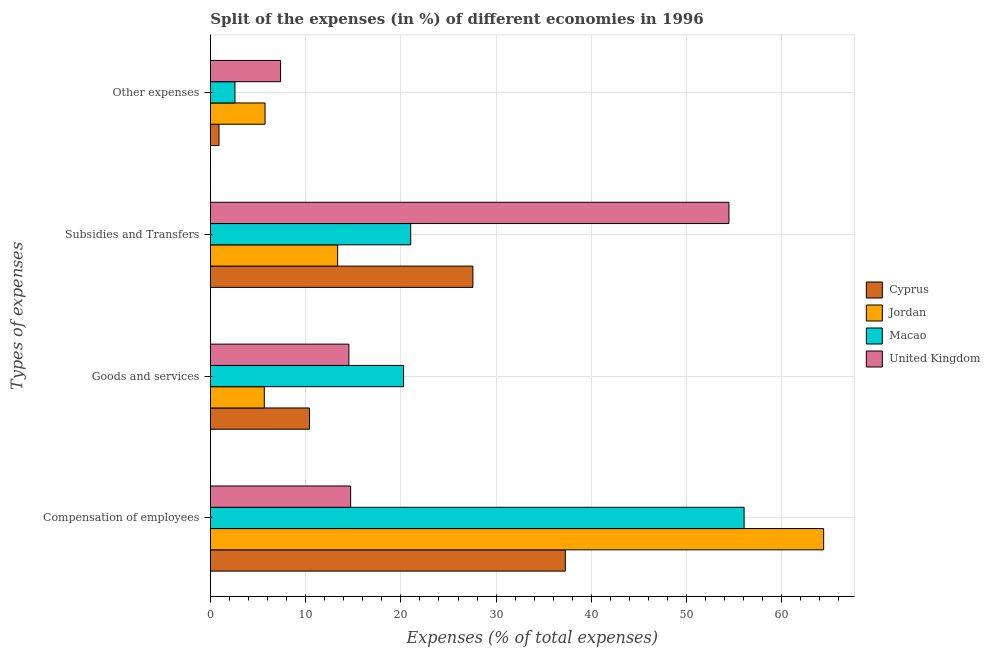How many groups of bars are there?
Offer a terse response. 4. How many bars are there on the 4th tick from the top?
Offer a very short reply. 4. How many bars are there on the 2nd tick from the bottom?
Ensure brevity in your answer.  4. What is the label of the 1st group of bars from the top?
Keep it short and to the point. Other expenses. What is the percentage of amount spent on compensation of employees in United Kingdom?
Give a very brief answer. 14.73. Across all countries, what is the maximum percentage of amount spent on compensation of employees?
Give a very brief answer. 64.4. Across all countries, what is the minimum percentage of amount spent on other expenses?
Provide a succinct answer. 0.9. In which country was the percentage of amount spent on compensation of employees maximum?
Keep it short and to the point. Jordan. In which country was the percentage of amount spent on other expenses minimum?
Provide a succinct answer. Cyprus. What is the total percentage of amount spent on other expenses in the graph?
Your response must be concise. 16.59. What is the difference between the percentage of amount spent on compensation of employees in Cyprus and that in Jordan?
Offer a terse response. -27.13. What is the difference between the percentage of amount spent on goods and services in Macao and the percentage of amount spent on compensation of employees in Jordan?
Offer a very short reply. -44.11. What is the average percentage of amount spent on compensation of employees per country?
Ensure brevity in your answer.  43.11. What is the difference between the percentage of amount spent on other expenses and percentage of amount spent on compensation of employees in United Kingdom?
Your response must be concise. -7.36. What is the ratio of the percentage of amount spent on other expenses in Jordan to that in Cyprus?
Ensure brevity in your answer.  6.35. What is the difference between the highest and the second highest percentage of amount spent on other expenses?
Your answer should be compact. 1.63. What is the difference between the highest and the lowest percentage of amount spent on goods and services?
Your answer should be compact. 14.63. What does the 3rd bar from the top in Other expenses represents?
Your answer should be compact. Jordan. What does the 1st bar from the bottom in Compensation of employees represents?
Ensure brevity in your answer.  Cyprus. Is it the case that in every country, the sum of the percentage of amount spent on compensation of employees and percentage of amount spent on goods and services is greater than the percentage of amount spent on subsidies?
Ensure brevity in your answer.  No. How many countries are there in the graph?
Provide a short and direct response. 4. What is the difference between two consecutive major ticks on the X-axis?
Give a very brief answer. 10. Are the values on the major ticks of X-axis written in scientific E-notation?
Your response must be concise. No. Where does the legend appear in the graph?
Offer a very short reply. Center right. What is the title of the graph?
Give a very brief answer. Split of the expenses (in %) of different economies in 1996. Does "Netherlands" appear as one of the legend labels in the graph?
Your answer should be very brief. No. What is the label or title of the X-axis?
Provide a succinct answer. Expenses (% of total expenses). What is the label or title of the Y-axis?
Offer a terse response. Types of expenses. What is the Expenses (% of total expenses) of Cyprus in Compensation of employees?
Provide a short and direct response. 37.27. What is the Expenses (% of total expenses) of Jordan in Compensation of employees?
Give a very brief answer. 64.4. What is the Expenses (% of total expenses) of Macao in Compensation of employees?
Your answer should be very brief. 56.04. What is the Expenses (% of total expenses) of United Kingdom in Compensation of employees?
Provide a succinct answer. 14.73. What is the Expenses (% of total expenses) of Cyprus in Goods and services?
Your answer should be compact. 10.41. What is the Expenses (% of total expenses) in Jordan in Goods and services?
Keep it short and to the point. 5.66. What is the Expenses (% of total expenses) of Macao in Goods and services?
Make the answer very short. 20.29. What is the Expenses (% of total expenses) of United Kingdom in Goods and services?
Keep it short and to the point. 14.54. What is the Expenses (% of total expenses) of Cyprus in Subsidies and Transfers?
Give a very brief answer. 27.56. What is the Expenses (% of total expenses) of Jordan in Subsidies and Transfers?
Your answer should be compact. 13.36. What is the Expenses (% of total expenses) in Macao in Subsidies and Transfers?
Provide a short and direct response. 21.03. What is the Expenses (% of total expenses) in United Kingdom in Subsidies and Transfers?
Offer a terse response. 54.45. What is the Expenses (% of total expenses) of Cyprus in Other expenses?
Your answer should be very brief. 0.9. What is the Expenses (% of total expenses) of Jordan in Other expenses?
Give a very brief answer. 5.74. What is the Expenses (% of total expenses) of Macao in Other expenses?
Give a very brief answer. 2.58. What is the Expenses (% of total expenses) in United Kingdom in Other expenses?
Ensure brevity in your answer.  7.37. Across all Types of expenses, what is the maximum Expenses (% of total expenses) of Cyprus?
Keep it short and to the point. 37.27. Across all Types of expenses, what is the maximum Expenses (% of total expenses) in Jordan?
Keep it short and to the point. 64.4. Across all Types of expenses, what is the maximum Expenses (% of total expenses) in Macao?
Offer a terse response. 56.04. Across all Types of expenses, what is the maximum Expenses (% of total expenses) of United Kingdom?
Ensure brevity in your answer.  54.45. Across all Types of expenses, what is the minimum Expenses (% of total expenses) of Cyprus?
Ensure brevity in your answer.  0.9. Across all Types of expenses, what is the minimum Expenses (% of total expenses) of Jordan?
Offer a terse response. 5.66. Across all Types of expenses, what is the minimum Expenses (% of total expenses) of Macao?
Your answer should be compact. 2.58. Across all Types of expenses, what is the minimum Expenses (% of total expenses) of United Kingdom?
Your answer should be compact. 7.37. What is the total Expenses (% of total expenses) in Cyprus in the graph?
Ensure brevity in your answer.  76.14. What is the total Expenses (% of total expenses) in Jordan in the graph?
Ensure brevity in your answer.  89.16. What is the total Expenses (% of total expenses) in Macao in the graph?
Your response must be concise. 99.94. What is the total Expenses (% of total expenses) in United Kingdom in the graph?
Ensure brevity in your answer.  91.08. What is the difference between the Expenses (% of total expenses) of Cyprus in Compensation of employees and that in Goods and services?
Ensure brevity in your answer.  26.86. What is the difference between the Expenses (% of total expenses) of Jordan in Compensation of employees and that in Goods and services?
Provide a short and direct response. 58.73. What is the difference between the Expenses (% of total expenses) in Macao in Compensation of employees and that in Goods and services?
Keep it short and to the point. 35.75. What is the difference between the Expenses (% of total expenses) in United Kingdom in Compensation of employees and that in Goods and services?
Your answer should be very brief. 0.18. What is the difference between the Expenses (% of total expenses) of Cyprus in Compensation of employees and that in Subsidies and Transfers?
Make the answer very short. 9.71. What is the difference between the Expenses (% of total expenses) of Jordan in Compensation of employees and that in Subsidies and Transfers?
Provide a succinct answer. 51.03. What is the difference between the Expenses (% of total expenses) in Macao in Compensation of employees and that in Subsidies and Transfers?
Your response must be concise. 35.01. What is the difference between the Expenses (% of total expenses) in United Kingdom in Compensation of employees and that in Subsidies and Transfers?
Keep it short and to the point. -39.72. What is the difference between the Expenses (% of total expenses) in Cyprus in Compensation of employees and that in Other expenses?
Your answer should be compact. 36.37. What is the difference between the Expenses (% of total expenses) in Jordan in Compensation of employees and that in Other expenses?
Keep it short and to the point. 58.66. What is the difference between the Expenses (% of total expenses) in Macao in Compensation of employees and that in Other expenses?
Offer a terse response. 53.46. What is the difference between the Expenses (% of total expenses) in United Kingdom in Compensation of employees and that in Other expenses?
Make the answer very short. 7.36. What is the difference between the Expenses (% of total expenses) of Cyprus in Goods and services and that in Subsidies and Transfers?
Your response must be concise. -17.16. What is the difference between the Expenses (% of total expenses) of Jordan in Goods and services and that in Subsidies and Transfers?
Your answer should be very brief. -7.7. What is the difference between the Expenses (% of total expenses) in Macao in Goods and services and that in Subsidies and Transfers?
Give a very brief answer. -0.75. What is the difference between the Expenses (% of total expenses) of United Kingdom in Goods and services and that in Subsidies and Transfers?
Offer a very short reply. -39.91. What is the difference between the Expenses (% of total expenses) of Cyprus in Goods and services and that in Other expenses?
Offer a terse response. 9.5. What is the difference between the Expenses (% of total expenses) of Jordan in Goods and services and that in Other expenses?
Your response must be concise. -0.08. What is the difference between the Expenses (% of total expenses) in Macao in Goods and services and that in Other expenses?
Your response must be concise. 17.71. What is the difference between the Expenses (% of total expenses) of United Kingdom in Goods and services and that in Other expenses?
Your response must be concise. 7.17. What is the difference between the Expenses (% of total expenses) of Cyprus in Subsidies and Transfers and that in Other expenses?
Your answer should be compact. 26.66. What is the difference between the Expenses (% of total expenses) of Jordan in Subsidies and Transfers and that in Other expenses?
Your answer should be very brief. 7.62. What is the difference between the Expenses (% of total expenses) of Macao in Subsidies and Transfers and that in Other expenses?
Provide a succinct answer. 18.45. What is the difference between the Expenses (% of total expenses) of United Kingdom in Subsidies and Transfers and that in Other expenses?
Offer a terse response. 47.08. What is the difference between the Expenses (% of total expenses) in Cyprus in Compensation of employees and the Expenses (% of total expenses) in Jordan in Goods and services?
Make the answer very short. 31.61. What is the difference between the Expenses (% of total expenses) of Cyprus in Compensation of employees and the Expenses (% of total expenses) of Macao in Goods and services?
Ensure brevity in your answer.  16.98. What is the difference between the Expenses (% of total expenses) of Cyprus in Compensation of employees and the Expenses (% of total expenses) of United Kingdom in Goods and services?
Ensure brevity in your answer.  22.73. What is the difference between the Expenses (% of total expenses) of Jordan in Compensation of employees and the Expenses (% of total expenses) of Macao in Goods and services?
Provide a succinct answer. 44.11. What is the difference between the Expenses (% of total expenses) of Jordan in Compensation of employees and the Expenses (% of total expenses) of United Kingdom in Goods and services?
Your answer should be very brief. 49.85. What is the difference between the Expenses (% of total expenses) of Macao in Compensation of employees and the Expenses (% of total expenses) of United Kingdom in Goods and services?
Provide a succinct answer. 41.5. What is the difference between the Expenses (% of total expenses) of Cyprus in Compensation of employees and the Expenses (% of total expenses) of Jordan in Subsidies and Transfers?
Make the answer very short. 23.91. What is the difference between the Expenses (% of total expenses) of Cyprus in Compensation of employees and the Expenses (% of total expenses) of Macao in Subsidies and Transfers?
Your response must be concise. 16.24. What is the difference between the Expenses (% of total expenses) in Cyprus in Compensation of employees and the Expenses (% of total expenses) in United Kingdom in Subsidies and Transfers?
Offer a very short reply. -17.18. What is the difference between the Expenses (% of total expenses) of Jordan in Compensation of employees and the Expenses (% of total expenses) of Macao in Subsidies and Transfers?
Your response must be concise. 43.36. What is the difference between the Expenses (% of total expenses) in Jordan in Compensation of employees and the Expenses (% of total expenses) in United Kingdom in Subsidies and Transfers?
Provide a short and direct response. 9.95. What is the difference between the Expenses (% of total expenses) in Macao in Compensation of employees and the Expenses (% of total expenses) in United Kingdom in Subsidies and Transfers?
Keep it short and to the point. 1.59. What is the difference between the Expenses (% of total expenses) in Cyprus in Compensation of employees and the Expenses (% of total expenses) in Jordan in Other expenses?
Make the answer very short. 31.53. What is the difference between the Expenses (% of total expenses) of Cyprus in Compensation of employees and the Expenses (% of total expenses) of Macao in Other expenses?
Ensure brevity in your answer.  34.69. What is the difference between the Expenses (% of total expenses) in Cyprus in Compensation of employees and the Expenses (% of total expenses) in United Kingdom in Other expenses?
Give a very brief answer. 29.9. What is the difference between the Expenses (% of total expenses) in Jordan in Compensation of employees and the Expenses (% of total expenses) in Macao in Other expenses?
Your response must be concise. 61.82. What is the difference between the Expenses (% of total expenses) in Jordan in Compensation of employees and the Expenses (% of total expenses) in United Kingdom in Other expenses?
Provide a succinct answer. 57.03. What is the difference between the Expenses (% of total expenses) in Macao in Compensation of employees and the Expenses (% of total expenses) in United Kingdom in Other expenses?
Provide a short and direct response. 48.68. What is the difference between the Expenses (% of total expenses) of Cyprus in Goods and services and the Expenses (% of total expenses) of Jordan in Subsidies and Transfers?
Keep it short and to the point. -2.96. What is the difference between the Expenses (% of total expenses) of Cyprus in Goods and services and the Expenses (% of total expenses) of Macao in Subsidies and Transfers?
Make the answer very short. -10.63. What is the difference between the Expenses (% of total expenses) of Cyprus in Goods and services and the Expenses (% of total expenses) of United Kingdom in Subsidies and Transfers?
Your answer should be compact. -44.04. What is the difference between the Expenses (% of total expenses) in Jordan in Goods and services and the Expenses (% of total expenses) in Macao in Subsidies and Transfers?
Your answer should be compact. -15.37. What is the difference between the Expenses (% of total expenses) in Jordan in Goods and services and the Expenses (% of total expenses) in United Kingdom in Subsidies and Transfers?
Offer a very short reply. -48.79. What is the difference between the Expenses (% of total expenses) of Macao in Goods and services and the Expenses (% of total expenses) of United Kingdom in Subsidies and Transfers?
Your answer should be compact. -34.16. What is the difference between the Expenses (% of total expenses) in Cyprus in Goods and services and the Expenses (% of total expenses) in Jordan in Other expenses?
Your answer should be compact. 4.67. What is the difference between the Expenses (% of total expenses) in Cyprus in Goods and services and the Expenses (% of total expenses) in Macao in Other expenses?
Provide a short and direct response. 7.83. What is the difference between the Expenses (% of total expenses) in Cyprus in Goods and services and the Expenses (% of total expenses) in United Kingdom in Other expenses?
Offer a terse response. 3.04. What is the difference between the Expenses (% of total expenses) of Jordan in Goods and services and the Expenses (% of total expenses) of Macao in Other expenses?
Offer a very short reply. 3.08. What is the difference between the Expenses (% of total expenses) in Jordan in Goods and services and the Expenses (% of total expenses) in United Kingdom in Other expenses?
Your response must be concise. -1.71. What is the difference between the Expenses (% of total expenses) of Macao in Goods and services and the Expenses (% of total expenses) of United Kingdom in Other expenses?
Provide a short and direct response. 12.92. What is the difference between the Expenses (% of total expenses) of Cyprus in Subsidies and Transfers and the Expenses (% of total expenses) of Jordan in Other expenses?
Provide a short and direct response. 21.83. What is the difference between the Expenses (% of total expenses) of Cyprus in Subsidies and Transfers and the Expenses (% of total expenses) of Macao in Other expenses?
Your answer should be very brief. 24.98. What is the difference between the Expenses (% of total expenses) in Cyprus in Subsidies and Transfers and the Expenses (% of total expenses) in United Kingdom in Other expenses?
Your answer should be compact. 20.2. What is the difference between the Expenses (% of total expenses) in Jordan in Subsidies and Transfers and the Expenses (% of total expenses) in Macao in Other expenses?
Provide a short and direct response. 10.78. What is the difference between the Expenses (% of total expenses) in Jordan in Subsidies and Transfers and the Expenses (% of total expenses) in United Kingdom in Other expenses?
Offer a very short reply. 6. What is the difference between the Expenses (% of total expenses) of Macao in Subsidies and Transfers and the Expenses (% of total expenses) of United Kingdom in Other expenses?
Provide a succinct answer. 13.67. What is the average Expenses (% of total expenses) in Cyprus per Types of expenses?
Provide a succinct answer. 19.04. What is the average Expenses (% of total expenses) of Jordan per Types of expenses?
Provide a succinct answer. 22.29. What is the average Expenses (% of total expenses) in Macao per Types of expenses?
Provide a succinct answer. 24.99. What is the average Expenses (% of total expenses) of United Kingdom per Types of expenses?
Ensure brevity in your answer.  22.77. What is the difference between the Expenses (% of total expenses) of Cyprus and Expenses (% of total expenses) of Jordan in Compensation of employees?
Your answer should be compact. -27.13. What is the difference between the Expenses (% of total expenses) of Cyprus and Expenses (% of total expenses) of Macao in Compensation of employees?
Your response must be concise. -18.77. What is the difference between the Expenses (% of total expenses) of Cyprus and Expenses (% of total expenses) of United Kingdom in Compensation of employees?
Offer a very short reply. 22.54. What is the difference between the Expenses (% of total expenses) in Jordan and Expenses (% of total expenses) in Macao in Compensation of employees?
Give a very brief answer. 8.35. What is the difference between the Expenses (% of total expenses) of Jordan and Expenses (% of total expenses) of United Kingdom in Compensation of employees?
Your response must be concise. 49.67. What is the difference between the Expenses (% of total expenses) of Macao and Expenses (% of total expenses) of United Kingdom in Compensation of employees?
Offer a very short reply. 41.32. What is the difference between the Expenses (% of total expenses) in Cyprus and Expenses (% of total expenses) in Jordan in Goods and services?
Provide a short and direct response. 4.74. What is the difference between the Expenses (% of total expenses) of Cyprus and Expenses (% of total expenses) of Macao in Goods and services?
Your response must be concise. -9.88. What is the difference between the Expenses (% of total expenses) of Cyprus and Expenses (% of total expenses) of United Kingdom in Goods and services?
Your response must be concise. -4.14. What is the difference between the Expenses (% of total expenses) in Jordan and Expenses (% of total expenses) in Macao in Goods and services?
Make the answer very short. -14.63. What is the difference between the Expenses (% of total expenses) in Jordan and Expenses (% of total expenses) in United Kingdom in Goods and services?
Offer a very short reply. -8.88. What is the difference between the Expenses (% of total expenses) in Macao and Expenses (% of total expenses) in United Kingdom in Goods and services?
Give a very brief answer. 5.75. What is the difference between the Expenses (% of total expenses) in Cyprus and Expenses (% of total expenses) in Jordan in Subsidies and Transfers?
Your answer should be very brief. 14.2. What is the difference between the Expenses (% of total expenses) of Cyprus and Expenses (% of total expenses) of Macao in Subsidies and Transfers?
Provide a succinct answer. 6.53. What is the difference between the Expenses (% of total expenses) of Cyprus and Expenses (% of total expenses) of United Kingdom in Subsidies and Transfers?
Provide a short and direct response. -26.88. What is the difference between the Expenses (% of total expenses) of Jordan and Expenses (% of total expenses) of Macao in Subsidies and Transfers?
Ensure brevity in your answer.  -7.67. What is the difference between the Expenses (% of total expenses) of Jordan and Expenses (% of total expenses) of United Kingdom in Subsidies and Transfers?
Provide a succinct answer. -41.09. What is the difference between the Expenses (% of total expenses) of Macao and Expenses (% of total expenses) of United Kingdom in Subsidies and Transfers?
Make the answer very short. -33.41. What is the difference between the Expenses (% of total expenses) in Cyprus and Expenses (% of total expenses) in Jordan in Other expenses?
Your response must be concise. -4.84. What is the difference between the Expenses (% of total expenses) in Cyprus and Expenses (% of total expenses) in Macao in Other expenses?
Provide a short and direct response. -1.68. What is the difference between the Expenses (% of total expenses) in Cyprus and Expenses (% of total expenses) in United Kingdom in Other expenses?
Your answer should be very brief. -6.46. What is the difference between the Expenses (% of total expenses) in Jordan and Expenses (% of total expenses) in Macao in Other expenses?
Make the answer very short. 3.16. What is the difference between the Expenses (% of total expenses) in Jordan and Expenses (% of total expenses) in United Kingdom in Other expenses?
Offer a very short reply. -1.63. What is the difference between the Expenses (% of total expenses) of Macao and Expenses (% of total expenses) of United Kingdom in Other expenses?
Provide a short and direct response. -4.79. What is the ratio of the Expenses (% of total expenses) of Cyprus in Compensation of employees to that in Goods and services?
Keep it short and to the point. 3.58. What is the ratio of the Expenses (% of total expenses) of Jordan in Compensation of employees to that in Goods and services?
Ensure brevity in your answer.  11.38. What is the ratio of the Expenses (% of total expenses) in Macao in Compensation of employees to that in Goods and services?
Your response must be concise. 2.76. What is the ratio of the Expenses (% of total expenses) in United Kingdom in Compensation of employees to that in Goods and services?
Offer a very short reply. 1.01. What is the ratio of the Expenses (% of total expenses) of Cyprus in Compensation of employees to that in Subsidies and Transfers?
Offer a very short reply. 1.35. What is the ratio of the Expenses (% of total expenses) in Jordan in Compensation of employees to that in Subsidies and Transfers?
Give a very brief answer. 4.82. What is the ratio of the Expenses (% of total expenses) in Macao in Compensation of employees to that in Subsidies and Transfers?
Offer a terse response. 2.66. What is the ratio of the Expenses (% of total expenses) in United Kingdom in Compensation of employees to that in Subsidies and Transfers?
Offer a terse response. 0.27. What is the ratio of the Expenses (% of total expenses) in Cyprus in Compensation of employees to that in Other expenses?
Your answer should be compact. 41.24. What is the ratio of the Expenses (% of total expenses) of Jordan in Compensation of employees to that in Other expenses?
Your response must be concise. 11.22. What is the ratio of the Expenses (% of total expenses) in Macao in Compensation of employees to that in Other expenses?
Offer a very short reply. 21.73. What is the ratio of the Expenses (% of total expenses) in United Kingdom in Compensation of employees to that in Other expenses?
Make the answer very short. 2. What is the ratio of the Expenses (% of total expenses) in Cyprus in Goods and services to that in Subsidies and Transfers?
Make the answer very short. 0.38. What is the ratio of the Expenses (% of total expenses) in Jordan in Goods and services to that in Subsidies and Transfers?
Offer a very short reply. 0.42. What is the ratio of the Expenses (% of total expenses) of Macao in Goods and services to that in Subsidies and Transfers?
Make the answer very short. 0.96. What is the ratio of the Expenses (% of total expenses) of United Kingdom in Goods and services to that in Subsidies and Transfers?
Your answer should be very brief. 0.27. What is the ratio of the Expenses (% of total expenses) in Cyprus in Goods and services to that in Other expenses?
Offer a very short reply. 11.51. What is the ratio of the Expenses (% of total expenses) in Jordan in Goods and services to that in Other expenses?
Your answer should be compact. 0.99. What is the ratio of the Expenses (% of total expenses) in Macao in Goods and services to that in Other expenses?
Ensure brevity in your answer.  7.87. What is the ratio of the Expenses (% of total expenses) in United Kingdom in Goods and services to that in Other expenses?
Provide a short and direct response. 1.97. What is the ratio of the Expenses (% of total expenses) of Cyprus in Subsidies and Transfers to that in Other expenses?
Keep it short and to the point. 30.5. What is the ratio of the Expenses (% of total expenses) of Jordan in Subsidies and Transfers to that in Other expenses?
Make the answer very short. 2.33. What is the ratio of the Expenses (% of total expenses) in Macao in Subsidies and Transfers to that in Other expenses?
Give a very brief answer. 8.15. What is the ratio of the Expenses (% of total expenses) in United Kingdom in Subsidies and Transfers to that in Other expenses?
Offer a terse response. 7.39. What is the difference between the highest and the second highest Expenses (% of total expenses) in Cyprus?
Offer a very short reply. 9.71. What is the difference between the highest and the second highest Expenses (% of total expenses) of Jordan?
Ensure brevity in your answer.  51.03. What is the difference between the highest and the second highest Expenses (% of total expenses) of Macao?
Give a very brief answer. 35.01. What is the difference between the highest and the second highest Expenses (% of total expenses) in United Kingdom?
Your answer should be compact. 39.72. What is the difference between the highest and the lowest Expenses (% of total expenses) of Cyprus?
Make the answer very short. 36.37. What is the difference between the highest and the lowest Expenses (% of total expenses) in Jordan?
Your response must be concise. 58.73. What is the difference between the highest and the lowest Expenses (% of total expenses) of Macao?
Provide a succinct answer. 53.46. What is the difference between the highest and the lowest Expenses (% of total expenses) in United Kingdom?
Ensure brevity in your answer.  47.08. 